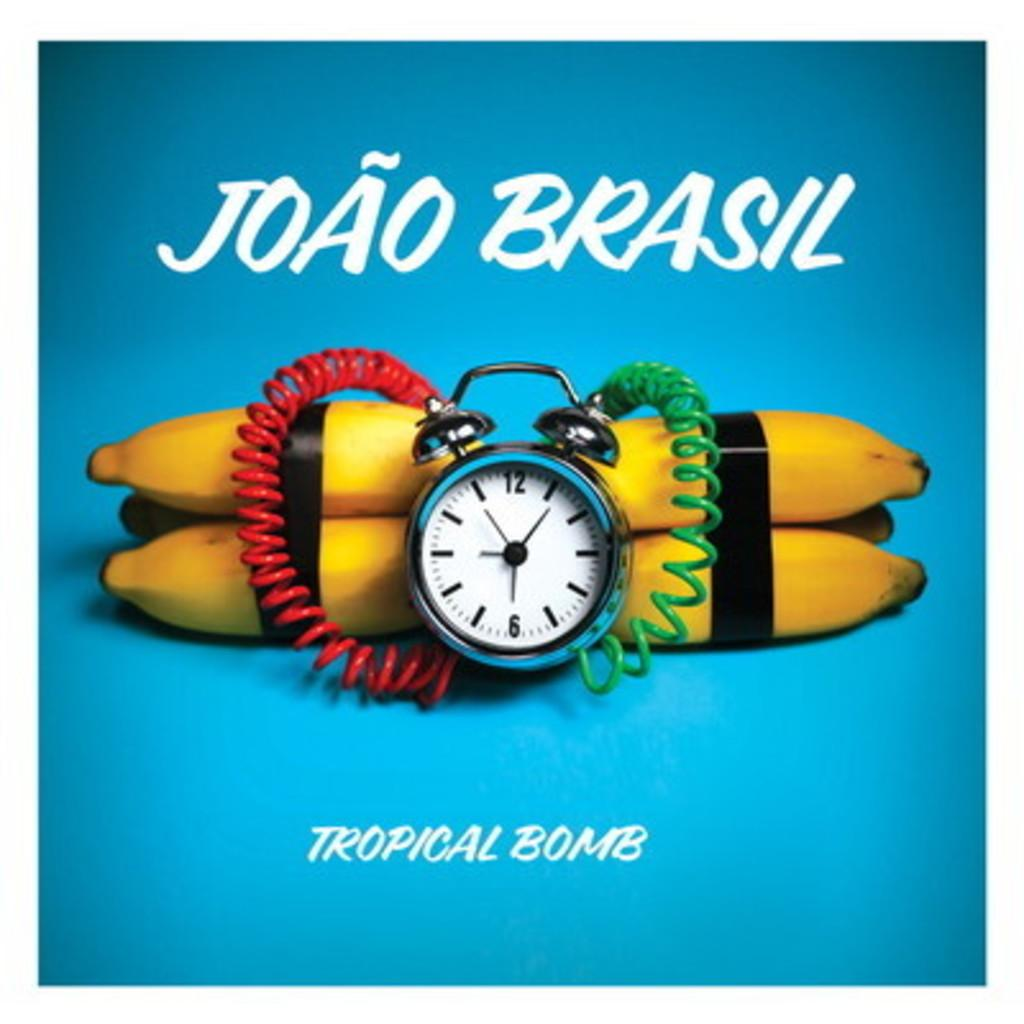<image>
Share a concise interpretation of the image provided. A graphic of bananas and a clock with a tag line of "Tropical Bomb." 